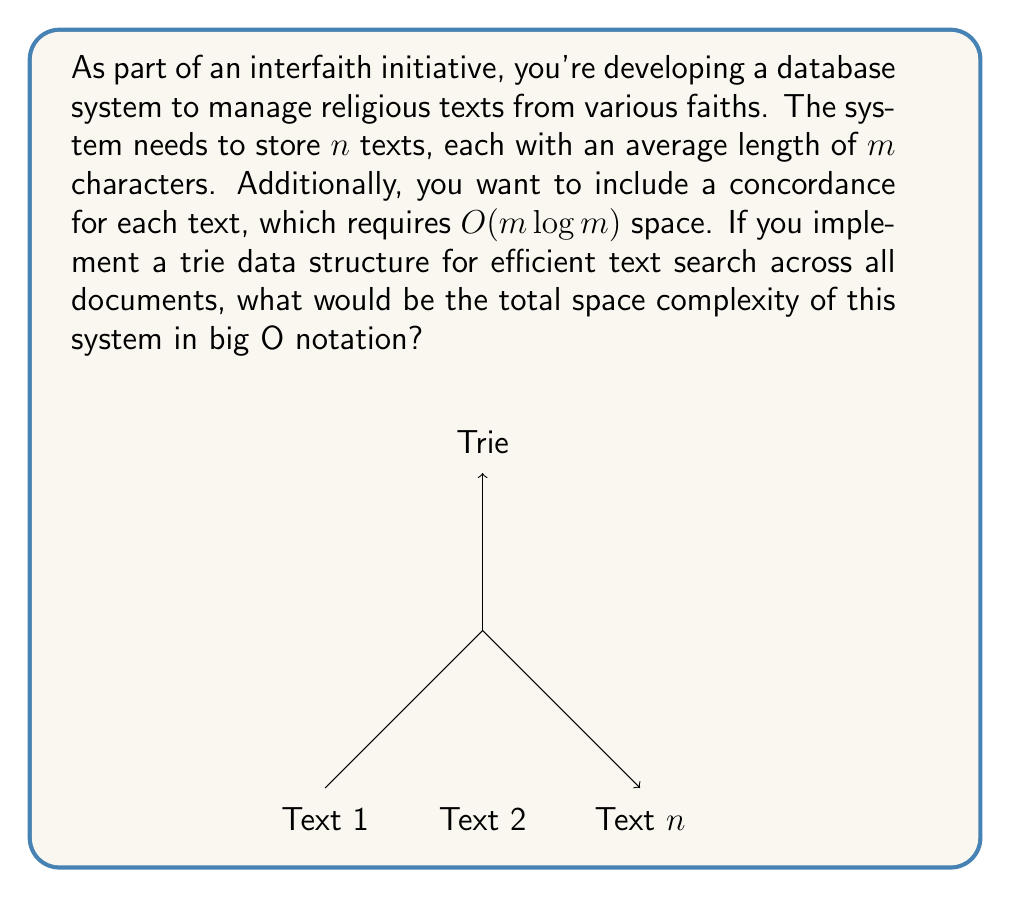Provide a solution to this math problem. Let's break this down step-by-step:

1) Storage for the texts themselves:
   - There are $n$ texts, each with $m$ characters on average.
   - Space required: $O(nm)$

2) Storage for concordances:
   - Each text requires $O(m \log m)$ space for its concordance.
   - There are $n$ texts.
   - Total space for concordances: $O(nm \log m)$

3) Trie data structure:
   - In the worst case, where all texts are entirely different, the trie would contain all characters from all texts.
   - Total characters: $nm$
   - Space complexity of trie: $O(nm)$

4) Combining all components:
   - Texts: $O(nm)$
   - Concordances: $O(nm \log m)$
   - Trie: $O(nm)$

5) The total space complexity is the sum of these components:
   $O(nm) + O(nm \log m) + O(nm)$

6) Simplifying:
   $O(nm + nm \log m + nm)$ = $O(nm + nm \log m)$

7) The dominant term is $nm \log m$, so we can further simplify to:
   $O(nm \log m)$

Therefore, the total space complexity of the system is $O(nm \log m)$.
Answer: $O(nm \log m)$ 